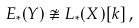Convert formula to latex. <formula><loc_0><loc_0><loc_500><loc_500>E _ { * } ( Y ) \not \cong L _ { * } ( X ) [ k ] \, ,</formula> 